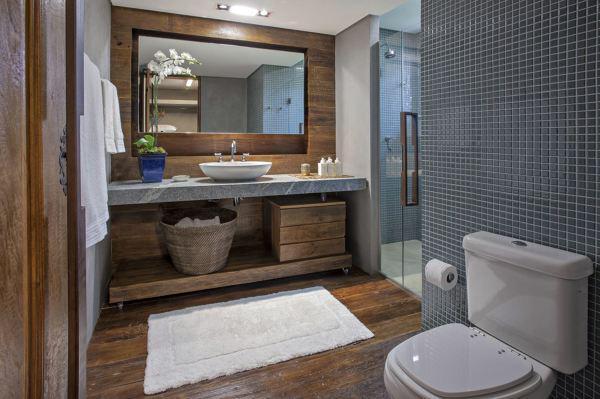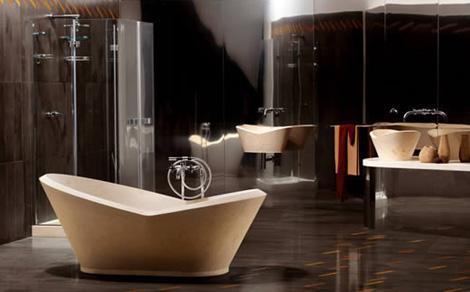The first image is the image on the left, the second image is the image on the right. Evaluate the accuracy of this statement regarding the images: "One image features a bathtub, and the other shows a vessel sink atop a counter with an open space and shelf beneath it.". Is it true? Answer yes or no. Yes. The first image is the image on the left, the second image is the image on the right. For the images displayed, is the sentence "One of the images contains a soft bath mat on the floor." factually correct? Answer yes or no. Yes. 